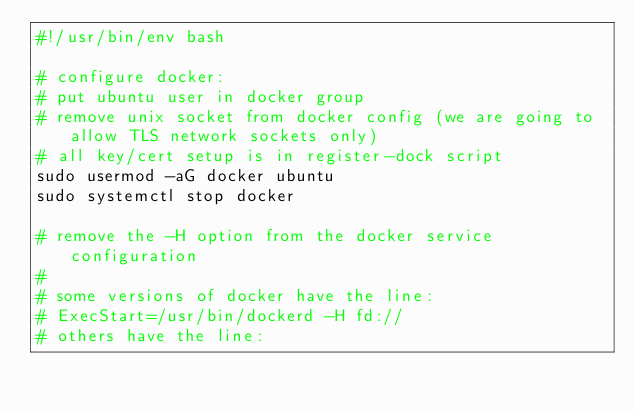Convert code to text. <code><loc_0><loc_0><loc_500><loc_500><_Bash_>#!/usr/bin/env bash

# configure docker:
# put ubuntu user in docker group
# remove unix socket from docker config (we are going to allow TLS network sockets only)
# all key/cert setup is in register-dock script
sudo usermod -aG docker ubuntu
sudo systemctl stop docker

# remove the -H option from the docker service configuration
#
# some versions of docker have the line:
# ExecStart=/usr/bin/dockerd -H fd://
# others have the line:</code> 